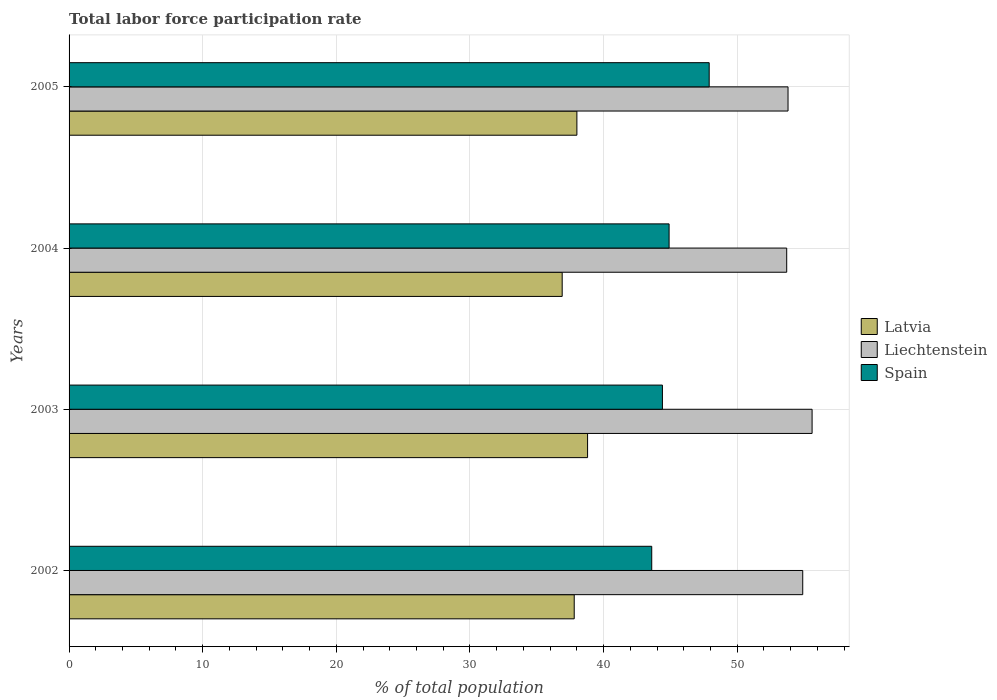Are the number of bars per tick equal to the number of legend labels?
Keep it short and to the point. Yes. Are the number of bars on each tick of the Y-axis equal?
Keep it short and to the point. Yes. How many bars are there on the 2nd tick from the bottom?
Make the answer very short. 3. In how many cases, is the number of bars for a given year not equal to the number of legend labels?
Offer a very short reply. 0. What is the total labor force participation rate in Latvia in 2003?
Your answer should be compact. 38.8. Across all years, what is the maximum total labor force participation rate in Liechtenstein?
Keep it short and to the point. 55.6. Across all years, what is the minimum total labor force participation rate in Liechtenstein?
Ensure brevity in your answer.  53.7. In which year was the total labor force participation rate in Liechtenstein maximum?
Offer a terse response. 2003. What is the total total labor force participation rate in Spain in the graph?
Keep it short and to the point. 180.8. What is the difference between the total labor force participation rate in Spain in 2003 and that in 2005?
Your answer should be compact. -3.5. What is the difference between the total labor force participation rate in Spain in 2004 and the total labor force participation rate in Latvia in 2005?
Give a very brief answer. 6.9. What is the average total labor force participation rate in Spain per year?
Your response must be concise. 45.2. In the year 2003, what is the difference between the total labor force participation rate in Liechtenstein and total labor force participation rate in Latvia?
Provide a succinct answer. 16.8. In how many years, is the total labor force participation rate in Liechtenstein greater than 34 %?
Your response must be concise. 4. What is the ratio of the total labor force participation rate in Spain in 2003 to that in 2005?
Give a very brief answer. 0.93. Is the total labor force participation rate in Spain in 2003 less than that in 2004?
Ensure brevity in your answer.  Yes. What is the difference between the highest and the second highest total labor force participation rate in Latvia?
Offer a very short reply. 0.8. What is the difference between the highest and the lowest total labor force participation rate in Spain?
Your answer should be very brief. 4.3. Is the sum of the total labor force participation rate in Latvia in 2002 and 2005 greater than the maximum total labor force participation rate in Liechtenstein across all years?
Offer a terse response. Yes. What does the 2nd bar from the top in 2002 represents?
Your answer should be compact. Liechtenstein. What does the 3rd bar from the bottom in 2003 represents?
Make the answer very short. Spain. Are all the bars in the graph horizontal?
Give a very brief answer. Yes. How many years are there in the graph?
Offer a very short reply. 4. Are the values on the major ticks of X-axis written in scientific E-notation?
Provide a succinct answer. No. Does the graph contain grids?
Keep it short and to the point. Yes. Where does the legend appear in the graph?
Your response must be concise. Center right. How many legend labels are there?
Your answer should be compact. 3. What is the title of the graph?
Your answer should be very brief. Total labor force participation rate. Does "Uganda" appear as one of the legend labels in the graph?
Provide a succinct answer. No. What is the label or title of the X-axis?
Offer a terse response. % of total population. What is the % of total population in Latvia in 2002?
Offer a terse response. 37.8. What is the % of total population in Liechtenstein in 2002?
Keep it short and to the point. 54.9. What is the % of total population of Spain in 2002?
Provide a succinct answer. 43.6. What is the % of total population of Latvia in 2003?
Your response must be concise. 38.8. What is the % of total population in Liechtenstein in 2003?
Your answer should be very brief. 55.6. What is the % of total population of Spain in 2003?
Your answer should be very brief. 44.4. What is the % of total population in Latvia in 2004?
Give a very brief answer. 36.9. What is the % of total population in Liechtenstein in 2004?
Your answer should be very brief. 53.7. What is the % of total population of Spain in 2004?
Your answer should be very brief. 44.9. What is the % of total population of Liechtenstein in 2005?
Your answer should be compact. 53.8. What is the % of total population in Spain in 2005?
Provide a succinct answer. 47.9. Across all years, what is the maximum % of total population of Latvia?
Your answer should be compact. 38.8. Across all years, what is the maximum % of total population of Liechtenstein?
Keep it short and to the point. 55.6. Across all years, what is the maximum % of total population in Spain?
Your response must be concise. 47.9. Across all years, what is the minimum % of total population in Latvia?
Give a very brief answer. 36.9. Across all years, what is the minimum % of total population of Liechtenstein?
Keep it short and to the point. 53.7. Across all years, what is the minimum % of total population of Spain?
Make the answer very short. 43.6. What is the total % of total population in Latvia in the graph?
Keep it short and to the point. 151.5. What is the total % of total population of Liechtenstein in the graph?
Offer a very short reply. 218. What is the total % of total population in Spain in the graph?
Offer a very short reply. 180.8. What is the difference between the % of total population in Latvia in 2002 and that in 2003?
Ensure brevity in your answer.  -1. What is the difference between the % of total population of Latvia in 2002 and that in 2004?
Provide a succinct answer. 0.9. What is the difference between the % of total population of Liechtenstein in 2002 and that in 2004?
Offer a terse response. 1.2. What is the difference between the % of total population in Spain in 2002 and that in 2004?
Ensure brevity in your answer.  -1.3. What is the difference between the % of total population in Latvia in 2002 and that in 2005?
Make the answer very short. -0.2. What is the difference between the % of total population in Spain in 2002 and that in 2005?
Ensure brevity in your answer.  -4.3. What is the difference between the % of total population in Latvia in 2003 and that in 2004?
Ensure brevity in your answer.  1.9. What is the difference between the % of total population of Liechtenstein in 2003 and that in 2004?
Provide a succinct answer. 1.9. What is the difference between the % of total population of Spain in 2003 and that in 2004?
Make the answer very short. -0.5. What is the difference between the % of total population of Spain in 2003 and that in 2005?
Provide a short and direct response. -3.5. What is the difference between the % of total population of Spain in 2004 and that in 2005?
Ensure brevity in your answer.  -3. What is the difference between the % of total population of Latvia in 2002 and the % of total population of Liechtenstein in 2003?
Provide a succinct answer. -17.8. What is the difference between the % of total population in Latvia in 2002 and the % of total population in Liechtenstein in 2004?
Give a very brief answer. -15.9. What is the difference between the % of total population in Latvia in 2002 and the % of total population in Spain in 2004?
Provide a succinct answer. -7.1. What is the difference between the % of total population in Liechtenstein in 2002 and the % of total population in Spain in 2004?
Keep it short and to the point. 10. What is the difference between the % of total population of Latvia in 2002 and the % of total population of Spain in 2005?
Your answer should be compact. -10.1. What is the difference between the % of total population in Latvia in 2003 and the % of total population in Liechtenstein in 2004?
Your response must be concise. -14.9. What is the difference between the % of total population of Latvia in 2003 and the % of total population of Spain in 2004?
Offer a very short reply. -6.1. What is the difference between the % of total population of Liechtenstein in 2003 and the % of total population of Spain in 2004?
Offer a terse response. 10.7. What is the difference between the % of total population in Latvia in 2003 and the % of total population in Liechtenstein in 2005?
Provide a succinct answer. -15. What is the difference between the % of total population in Latvia in 2003 and the % of total population in Spain in 2005?
Make the answer very short. -9.1. What is the difference between the % of total population in Liechtenstein in 2003 and the % of total population in Spain in 2005?
Your answer should be very brief. 7.7. What is the difference between the % of total population in Latvia in 2004 and the % of total population in Liechtenstein in 2005?
Give a very brief answer. -16.9. What is the difference between the % of total population of Latvia in 2004 and the % of total population of Spain in 2005?
Ensure brevity in your answer.  -11. What is the difference between the % of total population of Liechtenstein in 2004 and the % of total population of Spain in 2005?
Provide a short and direct response. 5.8. What is the average % of total population of Latvia per year?
Make the answer very short. 37.88. What is the average % of total population in Liechtenstein per year?
Your answer should be compact. 54.5. What is the average % of total population of Spain per year?
Offer a very short reply. 45.2. In the year 2002, what is the difference between the % of total population of Latvia and % of total population of Liechtenstein?
Offer a very short reply. -17.1. In the year 2002, what is the difference between the % of total population of Liechtenstein and % of total population of Spain?
Keep it short and to the point. 11.3. In the year 2003, what is the difference between the % of total population of Latvia and % of total population of Liechtenstein?
Keep it short and to the point. -16.8. In the year 2003, what is the difference between the % of total population in Latvia and % of total population in Spain?
Provide a short and direct response. -5.6. In the year 2004, what is the difference between the % of total population of Latvia and % of total population of Liechtenstein?
Provide a succinct answer. -16.8. In the year 2004, what is the difference between the % of total population of Latvia and % of total population of Spain?
Offer a terse response. -8. In the year 2005, what is the difference between the % of total population in Latvia and % of total population in Liechtenstein?
Provide a succinct answer. -15.8. In the year 2005, what is the difference between the % of total population in Latvia and % of total population in Spain?
Your response must be concise. -9.9. In the year 2005, what is the difference between the % of total population in Liechtenstein and % of total population in Spain?
Offer a terse response. 5.9. What is the ratio of the % of total population of Latvia in 2002 to that in 2003?
Your answer should be very brief. 0.97. What is the ratio of the % of total population of Liechtenstein in 2002 to that in 2003?
Make the answer very short. 0.99. What is the ratio of the % of total population in Latvia in 2002 to that in 2004?
Make the answer very short. 1.02. What is the ratio of the % of total population of Liechtenstein in 2002 to that in 2004?
Give a very brief answer. 1.02. What is the ratio of the % of total population in Spain in 2002 to that in 2004?
Make the answer very short. 0.97. What is the ratio of the % of total population of Liechtenstein in 2002 to that in 2005?
Make the answer very short. 1.02. What is the ratio of the % of total population of Spain in 2002 to that in 2005?
Offer a terse response. 0.91. What is the ratio of the % of total population in Latvia in 2003 to that in 2004?
Provide a short and direct response. 1.05. What is the ratio of the % of total population of Liechtenstein in 2003 to that in 2004?
Ensure brevity in your answer.  1.04. What is the ratio of the % of total population in Spain in 2003 to that in 2004?
Make the answer very short. 0.99. What is the ratio of the % of total population of Latvia in 2003 to that in 2005?
Your response must be concise. 1.02. What is the ratio of the % of total population of Liechtenstein in 2003 to that in 2005?
Offer a terse response. 1.03. What is the ratio of the % of total population in Spain in 2003 to that in 2005?
Your response must be concise. 0.93. What is the ratio of the % of total population in Latvia in 2004 to that in 2005?
Give a very brief answer. 0.97. What is the ratio of the % of total population in Liechtenstein in 2004 to that in 2005?
Your answer should be very brief. 1. What is the ratio of the % of total population of Spain in 2004 to that in 2005?
Your response must be concise. 0.94. What is the difference between the highest and the second highest % of total population of Liechtenstein?
Give a very brief answer. 0.7. What is the difference between the highest and the lowest % of total population in Latvia?
Ensure brevity in your answer.  1.9. What is the difference between the highest and the lowest % of total population of Spain?
Keep it short and to the point. 4.3. 